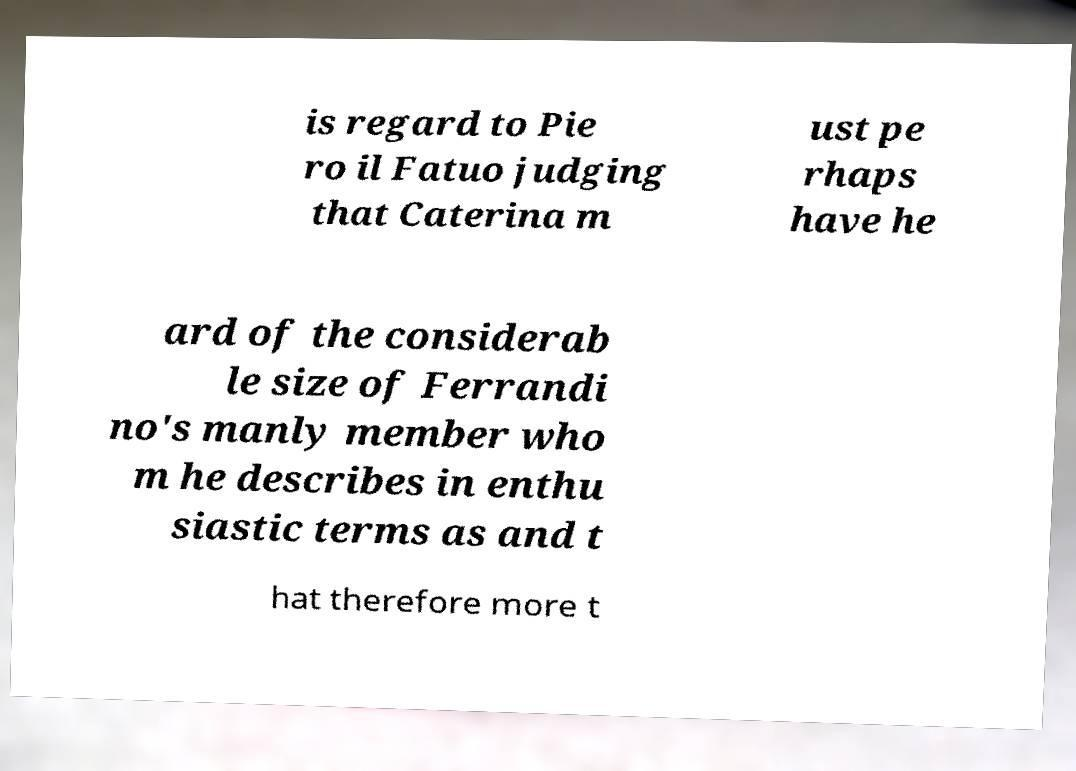Can you accurately transcribe the text from the provided image for me? is regard to Pie ro il Fatuo judging that Caterina m ust pe rhaps have he ard of the considerab le size of Ferrandi no's manly member who m he describes in enthu siastic terms as and t hat therefore more t 